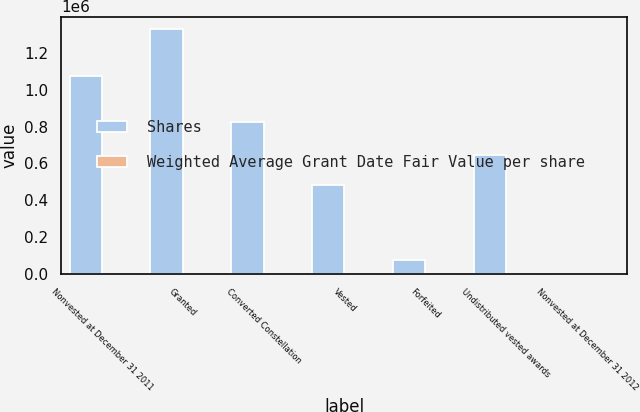Convert chart. <chart><loc_0><loc_0><loc_500><loc_500><stacked_bar_chart><ecel><fcel>Nonvested at December 31 2011<fcel>Granted<fcel>Converted Constellation<fcel>Vested<fcel>Forfeited<fcel>Undistributed vested awards<fcel>Nonvested at December 31 2012<nl><fcel>Shares<fcel>1.07448e+06<fcel>1.33221e+06<fcel>825735<fcel>479805<fcel>76484<fcel>646983<fcel>48.08<nl><fcel>Weighted Average Grant Date Fair Value per share<fcel>48.08<fcel>39.94<fcel>38.91<fcel>46.36<fcel>42.21<fcel>40.75<fcel>42.12<nl></chart> 